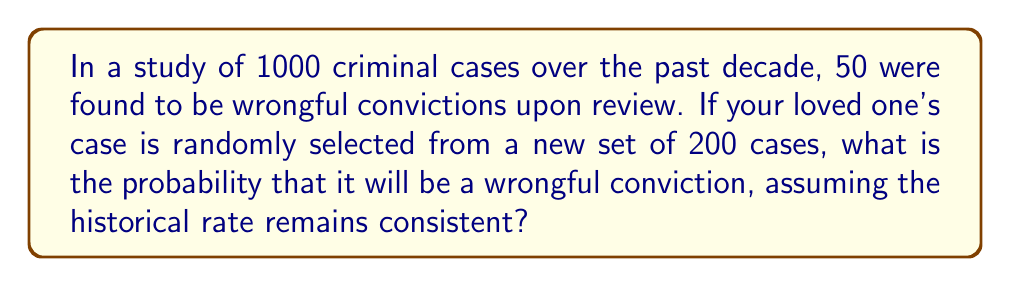What is the answer to this math problem? To solve this problem, we'll follow these steps:

1) First, we need to calculate the probability of a wrongful conviction based on the historical data:

   $$P(\text{wrongful conviction}) = \frac{\text{number of wrongful convictions}}{\text{total number of cases}}$$

   $$P(\text{wrongful conviction}) = \frac{50}{1000} = 0.05 = 5\%$$

2) Now, we assume that this probability remains consistent for the new set of cases.

3) The question is essentially asking for the probability of a single trial (selecting your loved one's case) resulting in a "success" (being a wrongful conviction), given this historical probability.

4) This scenario follows a Bernoulli distribution, where the probability of success on a single trial is 0.05.

5) Therefore, the probability that your loved one's case, when randomly selected from the new set, will be a wrongful conviction is simply 0.05 or 5%.

Note: The number of new cases (200) doesn't affect the probability in this scenario, as we're only concerned with a single case selection.
Answer: 0.05 